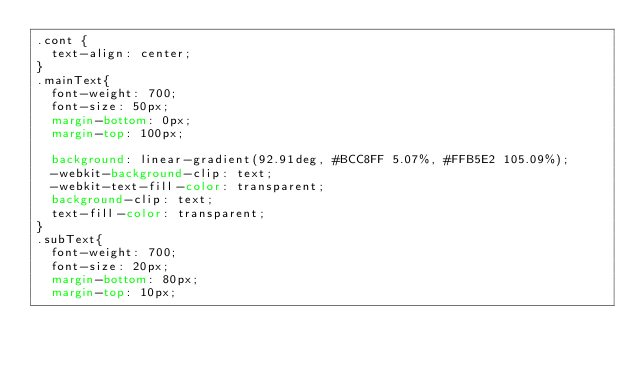<code> <loc_0><loc_0><loc_500><loc_500><_CSS_>.cont {
  text-align: center;
}
.mainText{
  font-weight: 700;
  font-size: 50px;
  margin-bottom: 0px;
  margin-top: 100px;
  
  background: linear-gradient(92.91deg, #BCC8FF 5.07%, #FFB5E2 105.09%);
  -webkit-background-clip: text;
  -webkit-text-fill-color: transparent;
  background-clip: text;
  text-fill-color: transparent;
}
.subText{
  font-weight: 700;
  font-size: 20px;
  margin-bottom: 80px;
  margin-top: 10px;</code> 